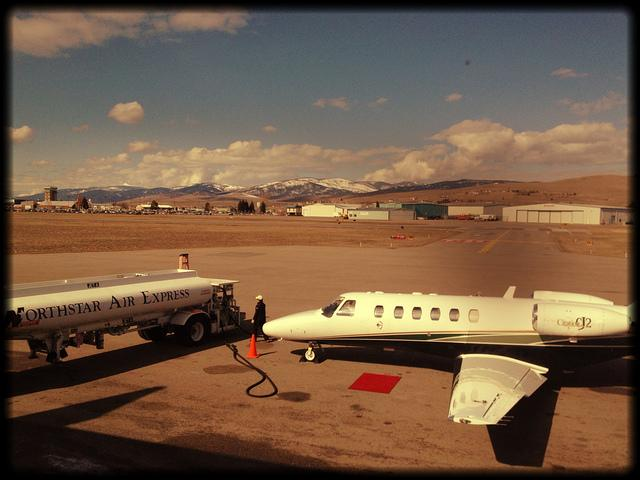What is northstar air express responsible for? Please explain your reasoning. refueling. There is a fuel truck there to put more fuel in the plane. 